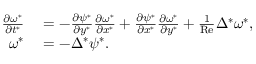<formula> <loc_0><loc_0><loc_500><loc_500>\begin{array} { r l } { \frac { \partial \omega ^ { * } } { \partial t ^ { * } } } & = - \frac { \partial \psi ^ { * } } { \partial y ^ { * } } \frac { \partial \omega ^ { * } } { \partial x ^ { * } } + \frac { \partial \psi ^ { * } } { \partial x ^ { * } } \frac { \partial \omega ^ { * } } { \partial y ^ { * } } + \frac { 1 } { R e } \Delta ^ { * } \omega ^ { * } , } \\ { \omega ^ { * } } & = - \Delta ^ { * } \psi ^ { * } . } \end{array}</formula> 